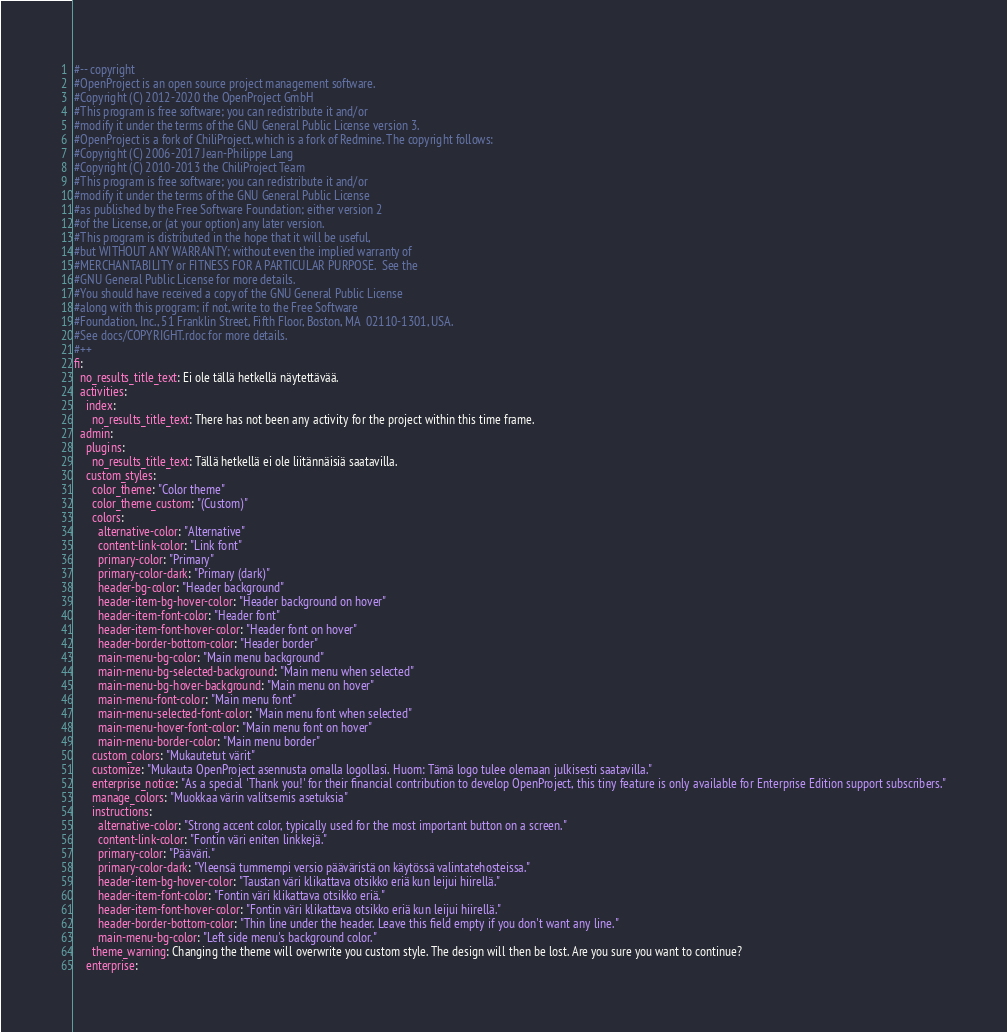Convert code to text. <code><loc_0><loc_0><loc_500><loc_500><_YAML_>#-- copyright
#OpenProject is an open source project management software.
#Copyright (C) 2012-2020 the OpenProject GmbH
#This program is free software; you can redistribute it and/or
#modify it under the terms of the GNU General Public License version 3.
#OpenProject is a fork of ChiliProject, which is a fork of Redmine. The copyright follows:
#Copyright (C) 2006-2017 Jean-Philippe Lang
#Copyright (C) 2010-2013 the ChiliProject Team
#This program is free software; you can redistribute it and/or
#modify it under the terms of the GNU General Public License
#as published by the Free Software Foundation; either version 2
#of the License, or (at your option) any later version.
#This program is distributed in the hope that it will be useful,
#but WITHOUT ANY WARRANTY; without even the implied warranty of
#MERCHANTABILITY or FITNESS FOR A PARTICULAR PURPOSE.  See the
#GNU General Public License for more details.
#You should have received a copy of the GNU General Public License
#along with this program; if not, write to the Free Software
#Foundation, Inc., 51 Franklin Street, Fifth Floor, Boston, MA  02110-1301, USA.
#See docs/COPYRIGHT.rdoc for more details.
#++
fi:
  no_results_title_text: Ei ole tällä hetkellä näytettävää.
  activities:
    index:
      no_results_title_text: There has not been any activity for the project within this time frame.
  admin:
    plugins:
      no_results_title_text: Tällä hetkellä ei ole liitännäisiä saatavilla.
    custom_styles:
      color_theme: "Color theme"
      color_theme_custom: "(Custom)"
      colors:
        alternative-color: "Alternative"
        content-link-color: "Link font"
        primary-color: "Primary"
        primary-color-dark: "Primary (dark)"
        header-bg-color: "Header background"
        header-item-bg-hover-color: "Header background on hover"
        header-item-font-color: "Header font"
        header-item-font-hover-color: "Header font on hover"
        header-border-bottom-color: "Header border"
        main-menu-bg-color: "Main menu background"
        main-menu-bg-selected-background: "Main menu when selected"
        main-menu-bg-hover-background: "Main menu on hover"
        main-menu-font-color: "Main menu font"
        main-menu-selected-font-color: "Main menu font when selected"
        main-menu-hover-font-color: "Main menu font on hover"
        main-menu-border-color: "Main menu border"
      custom_colors: "Mukautetut värit"
      customize: "Mukauta OpenProject asennusta omalla logollasi. Huom: Tämä logo tulee olemaan julkisesti saatavilla."
      enterprise_notice: "As a special 'Thank you!' for their financial contribution to develop OpenProject, this tiny feature is only available for Enterprise Edition support subscribers."
      manage_colors: "Muokkaa värin valitsemis asetuksia"
      instructions:
        alternative-color: "Strong accent color, typically used for the most important button on a screen."
        content-link-color: "Fontin väri eniten linkkejä."
        primary-color: "Pääväri."
        primary-color-dark: "Yleensä tummempi versio pääväristä on käytössä valintatehosteissa."
        header-item-bg-hover-color: "Taustan väri klikattava otsikko eriä kun leijui hiirellä."
        header-item-font-color: "Fontin väri klikattava otsikko eriä."
        header-item-font-hover-color: "Fontin väri klikattava otsikko eriä kun leijui hiirellä."
        header-border-bottom-color: "Thin line under the header. Leave this field empty if you don't want any line."
        main-menu-bg-color: "Left side menu's background color."
      theme_warning: Changing the theme will overwrite you custom style. The design will then be lost. Are you sure you want to continue?
    enterprise:</code> 